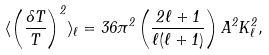<formula> <loc_0><loc_0><loc_500><loc_500>\langle \left ( \frac { \delta T } { T } \right ) ^ { 2 } \rangle _ { \ell } = { 3 6 \pi ^ { 2 } } \left ( \frac { 2 \ell + 1 } { \ell ( \ell + 1 ) } \right ) { A ^ { 2 } } K _ { \ell } ^ { 2 } ,</formula> 